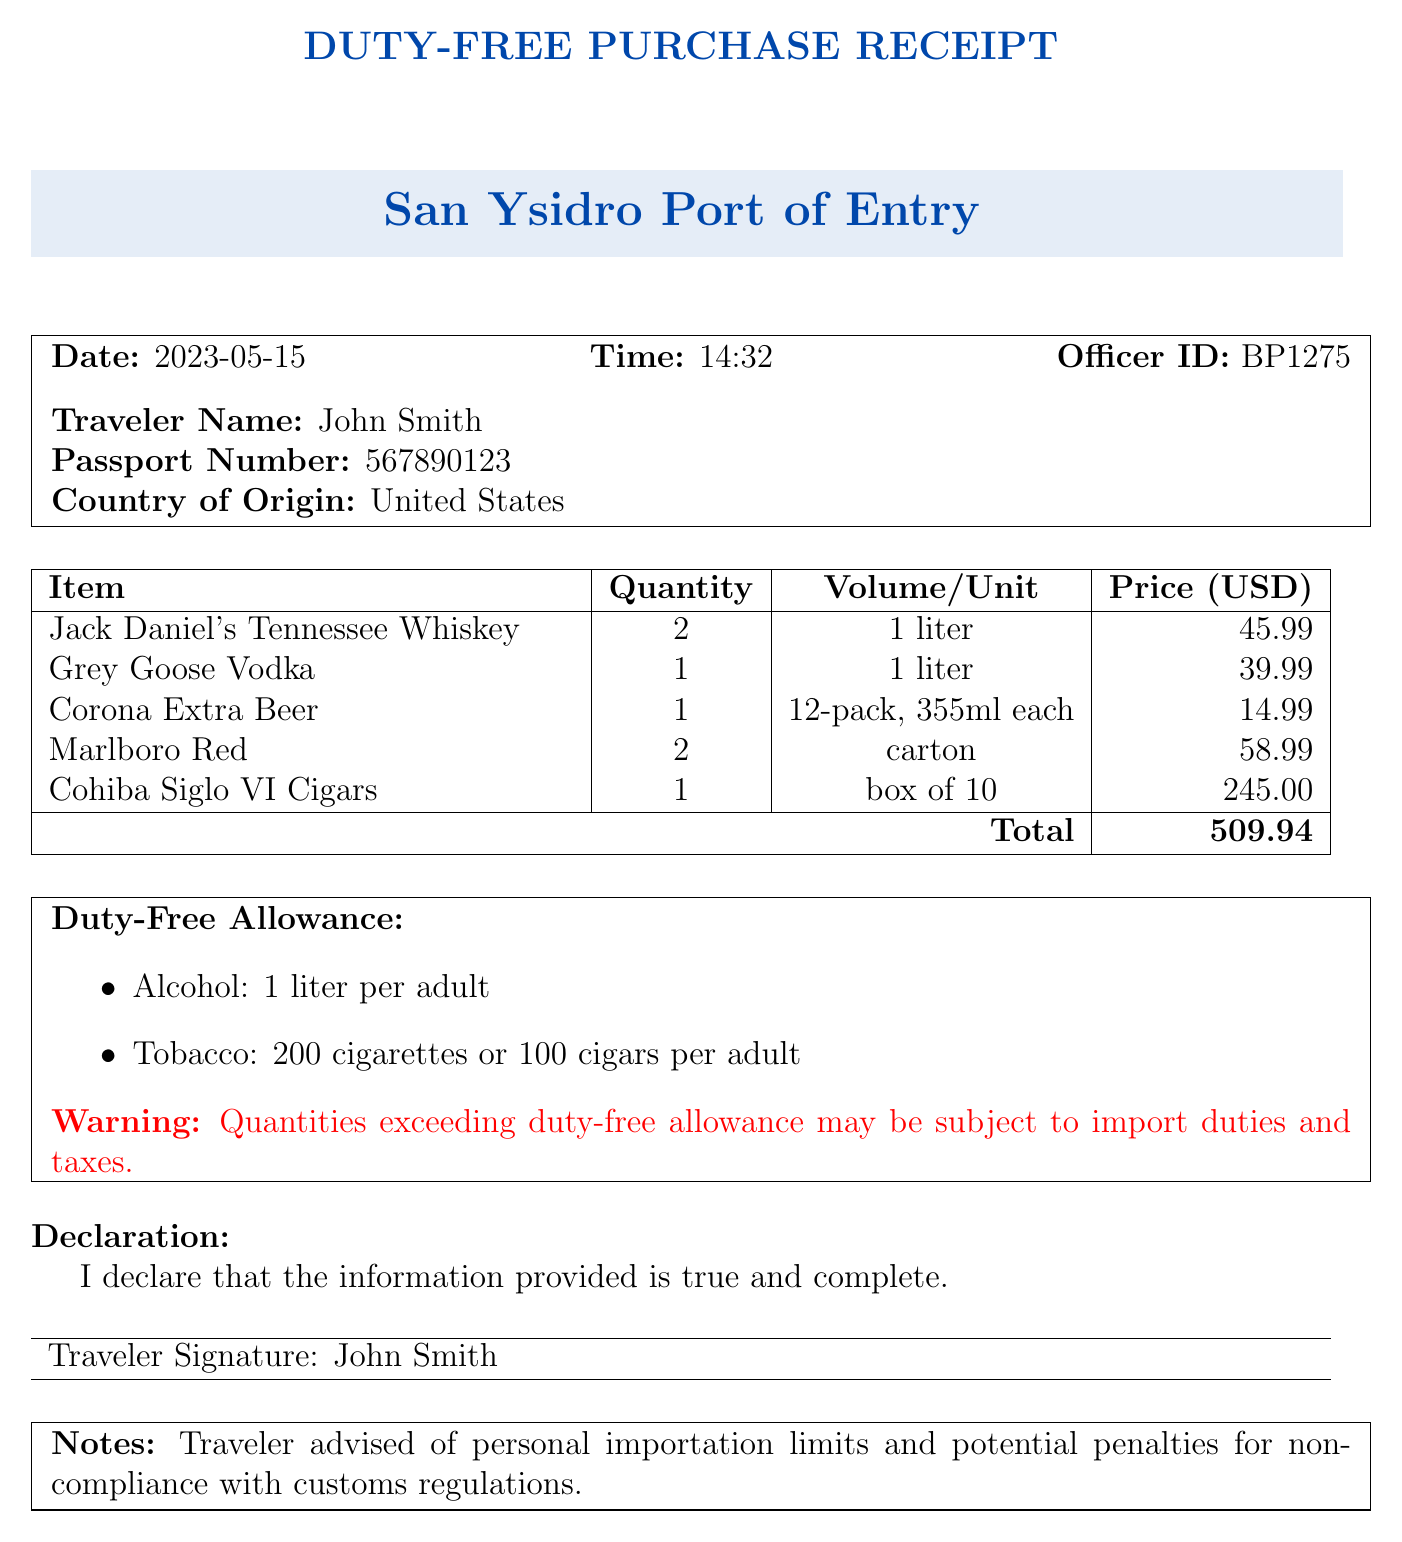what is the date of the border crossing? The date is clearly stated in the document as the date of the border crossing.
Answer: 2023-05-15 who is the traveler? The document identifies the traveler by name, which is explicitly mentioned.
Answer: John Smith how much alcohol is allowed per adult duty-free? The duty-free allowance section provides specific limits, which can be quoted directly.
Answer: 1 liter per adult what is the total price of the duty-free purchases? The total price is given in the document, summarizing the costs of all items.
Answer: 509.94 what is the officer ID? The officer ID is included in the header section of the document for identification purposes.
Answer: BP1275 how many liters of Jack Daniel's were purchased? The itemized list specifies the quantity of Jack Daniel's purchased.
Answer: 2 what are the potential penalties for non-compliance? The notes section in the document mentions advisement regarding penalties.
Answer: Potential penalties for non-compliance with customs regulations how many Marlboro Red cartons were purchased? The quantity of Marlboro Red is detailed in the itemized list.
Answer: 2 what is the warning about excess duty? The document has a specific warning related to exceeding duty-free allowances.
Answer: Quantities exceeding duty-free allowance may be subject to import duties and taxes 